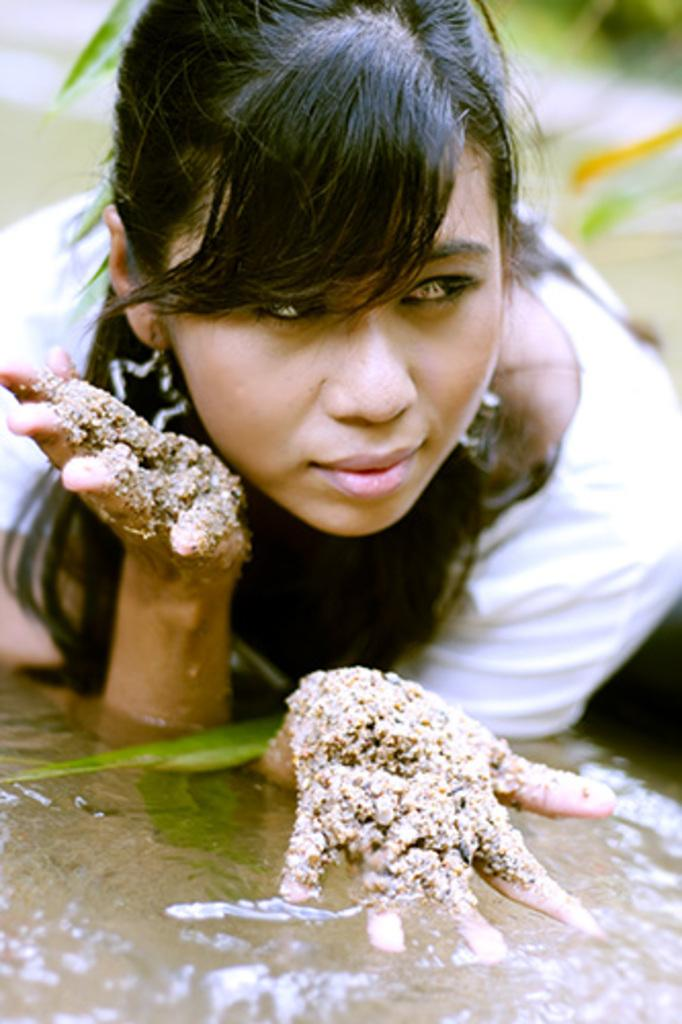Who is present in the image? There is a woman in the image. What is the woman doing in the image? The woman is lying in the water. Can you describe the water in the image? The water is described as mud. What type of watch can be seen on the woman's wrist in the image? There is no watch visible on the woman's wrist in the image. 